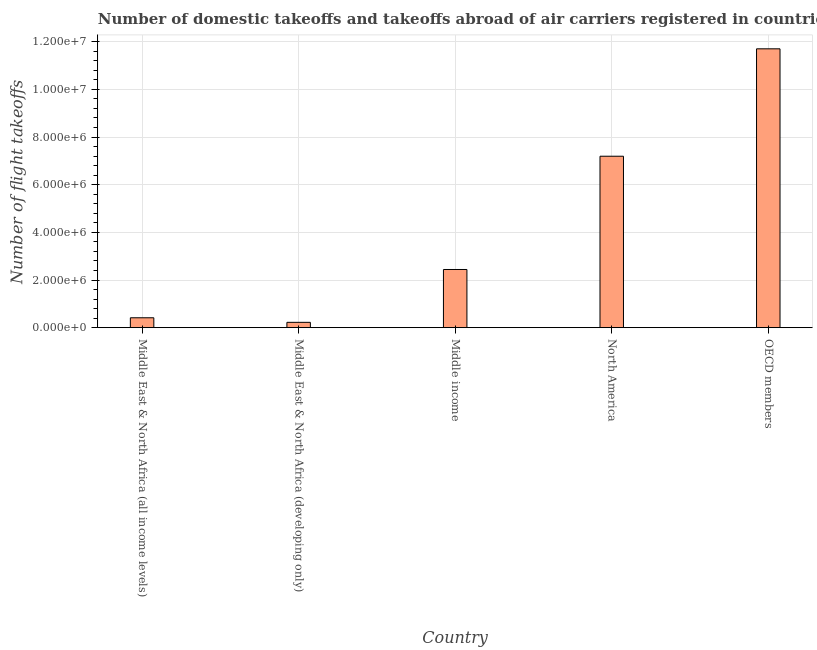Does the graph contain grids?
Give a very brief answer. Yes. What is the title of the graph?
Offer a very short reply. Number of domestic takeoffs and takeoffs abroad of air carriers registered in countries. What is the label or title of the X-axis?
Provide a succinct answer. Country. What is the label or title of the Y-axis?
Ensure brevity in your answer.  Number of flight takeoffs. What is the number of flight takeoffs in North America?
Your response must be concise. 7.20e+06. Across all countries, what is the maximum number of flight takeoffs?
Give a very brief answer. 1.17e+07. Across all countries, what is the minimum number of flight takeoffs?
Give a very brief answer. 2.23e+05. In which country was the number of flight takeoffs maximum?
Your response must be concise. OECD members. In which country was the number of flight takeoffs minimum?
Offer a very short reply. Middle East & North Africa (developing only). What is the sum of the number of flight takeoffs?
Offer a terse response. 2.20e+07. What is the difference between the number of flight takeoffs in North America and OECD members?
Provide a succinct answer. -4.51e+06. What is the average number of flight takeoffs per country?
Make the answer very short. 4.40e+06. What is the median number of flight takeoffs?
Keep it short and to the point. 2.44e+06. What is the ratio of the number of flight takeoffs in Middle East & North Africa (developing only) to that in Middle income?
Provide a succinct answer. 0.09. Is the number of flight takeoffs in Middle East & North Africa (developing only) less than that in North America?
Keep it short and to the point. Yes. Is the difference between the number of flight takeoffs in Middle East & North Africa (all income levels) and North America greater than the difference between any two countries?
Offer a very short reply. No. What is the difference between the highest and the second highest number of flight takeoffs?
Ensure brevity in your answer.  4.51e+06. Is the sum of the number of flight takeoffs in Middle East & North Africa (all income levels) and North America greater than the maximum number of flight takeoffs across all countries?
Ensure brevity in your answer.  No. What is the difference between the highest and the lowest number of flight takeoffs?
Offer a very short reply. 1.15e+07. How many bars are there?
Your answer should be very brief. 5. Are all the bars in the graph horizontal?
Ensure brevity in your answer.  No. How many countries are there in the graph?
Provide a succinct answer. 5. Are the values on the major ticks of Y-axis written in scientific E-notation?
Offer a very short reply. Yes. What is the Number of flight takeoffs in Middle East & North Africa (all income levels)?
Give a very brief answer. 4.15e+05. What is the Number of flight takeoffs of Middle East & North Africa (developing only)?
Ensure brevity in your answer.  2.23e+05. What is the Number of flight takeoffs of Middle income?
Provide a succinct answer. 2.44e+06. What is the Number of flight takeoffs in North America?
Your response must be concise. 7.20e+06. What is the Number of flight takeoffs in OECD members?
Keep it short and to the point. 1.17e+07. What is the difference between the Number of flight takeoffs in Middle East & North Africa (all income levels) and Middle East & North Africa (developing only)?
Offer a terse response. 1.92e+05. What is the difference between the Number of flight takeoffs in Middle East & North Africa (all income levels) and Middle income?
Provide a succinct answer. -2.03e+06. What is the difference between the Number of flight takeoffs in Middle East & North Africa (all income levels) and North America?
Provide a short and direct response. -6.78e+06. What is the difference between the Number of flight takeoffs in Middle East & North Africa (all income levels) and OECD members?
Offer a terse response. -1.13e+07. What is the difference between the Number of flight takeoffs in Middle East & North Africa (developing only) and Middle income?
Provide a succinct answer. -2.22e+06. What is the difference between the Number of flight takeoffs in Middle East & North Africa (developing only) and North America?
Offer a very short reply. -6.97e+06. What is the difference between the Number of flight takeoffs in Middle East & North Africa (developing only) and OECD members?
Make the answer very short. -1.15e+07. What is the difference between the Number of flight takeoffs in Middle income and North America?
Offer a very short reply. -4.75e+06. What is the difference between the Number of flight takeoffs in Middle income and OECD members?
Offer a terse response. -9.26e+06. What is the difference between the Number of flight takeoffs in North America and OECD members?
Give a very brief answer. -4.51e+06. What is the ratio of the Number of flight takeoffs in Middle East & North Africa (all income levels) to that in Middle East & North Africa (developing only)?
Keep it short and to the point. 1.86. What is the ratio of the Number of flight takeoffs in Middle East & North Africa (all income levels) to that in Middle income?
Give a very brief answer. 0.17. What is the ratio of the Number of flight takeoffs in Middle East & North Africa (all income levels) to that in North America?
Your answer should be very brief. 0.06. What is the ratio of the Number of flight takeoffs in Middle East & North Africa (all income levels) to that in OECD members?
Provide a short and direct response. 0.04. What is the ratio of the Number of flight takeoffs in Middle East & North Africa (developing only) to that in Middle income?
Keep it short and to the point. 0.09. What is the ratio of the Number of flight takeoffs in Middle East & North Africa (developing only) to that in North America?
Offer a terse response. 0.03. What is the ratio of the Number of flight takeoffs in Middle East & North Africa (developing only) to that in OECD members?
Make the answer very short. 0.02. What is the ratio of the Number of flight takeoffs in Middle income to that in North America?
Keep it short and to the point. 0.34. What is the ratio of the Number of flight takeoffs in Middle income to that in OECD members?
Provide a short and direct response. 0.21. What is the ratio of the Number of flight takeoffs in North America to that in OECD members?
Ensure brevity in your answer.  0.61. 